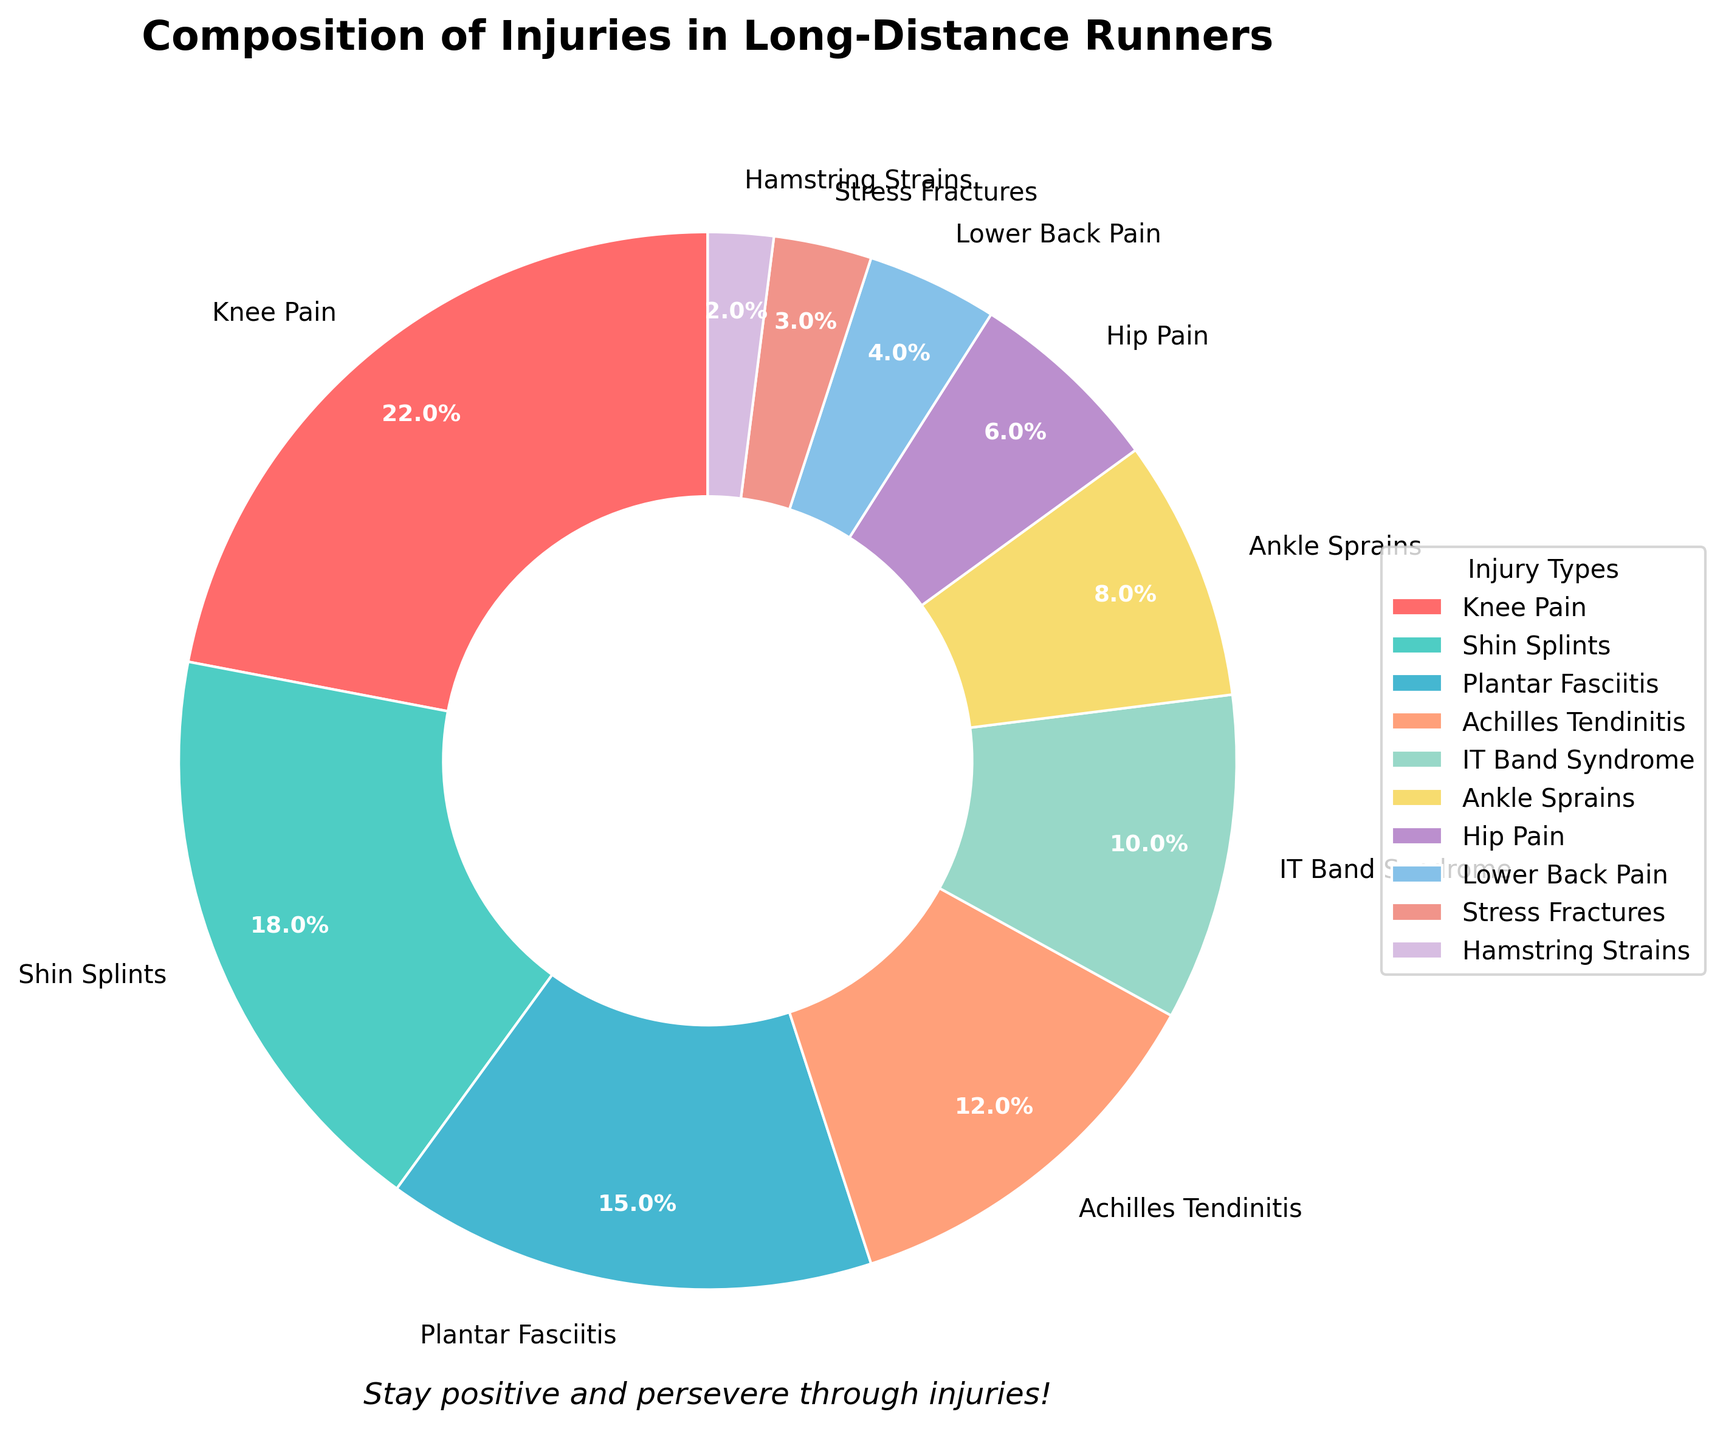What's the most common type of injury among long-distance runners? The pie chart shows various types of injuries and their respective proportions. Knee Pain has the largest slice with 22% of the total injuries.
Answer: Knee Pain Which injury types together make up more than a third of the total injuries? Adding the percentages of Knee Pain (22%) and Shin Splints (18%) gives 40%, which is more than a third of the total injuries.
Answer: Knee Pain and Shin Splints How much more prevalent is Knee Pain compared to Shin Splints? Knee Pain has a prevalence of 22%, whereas Shin Splints have 18%. The difference is 22% - 18% = 4%.
Answer: 4% Which injuries are least common (less than 5%) among long-distance runners? The pie chart shows that Stress Fractures and Hamstring Strains are the injury types with percentages less than 5%, specifically 3% and 2%, respectively.
Answer: Stress Fractures and Hamstring Strains What's the combined percentage of injuries related to the foot and ankle (Plantar Fasciitis and Ankle Sprains)? Plantar Fasciitis has 15% and Ankle Sprains have 8%. Together, they comprise 15% + 8% = 23%.
Answer: 23% Is IT Band Syndrome more common than Hip Pain? Yes, the pie chart shows IT Band Syndrome has 10% while Hip Pain has 6%, making IT Band Syndrome more common.
Answer: Yes Among the injuries less than 10%, which one has the highest percentage? The injuries less than 10% are Ankle Sprains (8%), Hip Pain (6%), Lower Back Pain (4%), Stress Fractures (3%), and Hamstring Strains (2%). Ankle Sprains have the highest percentage in this group.
Answer: Ankle Sprains What percentage of injuries is attributed to the lower back and hamstring combined? Lower Back Pain has 4% and Hamstring Strains have 2%. Combined, they account for 4% + 2% = 6%.
Answer: 6% Which injury types appear in cool colors in the chart? Cool colors typically include blue, green, and shades of purple. Shin Splints (green), IT Band Syndrome (blue), Hip Pain (purple), Lower Back Pain (blue), and Hamstring Strains (purple) are all in cool colors.
Answer: Shin Splints, IT Band Syndrome, Hip Pain, Lower Back Pain, Hamstring Strains 